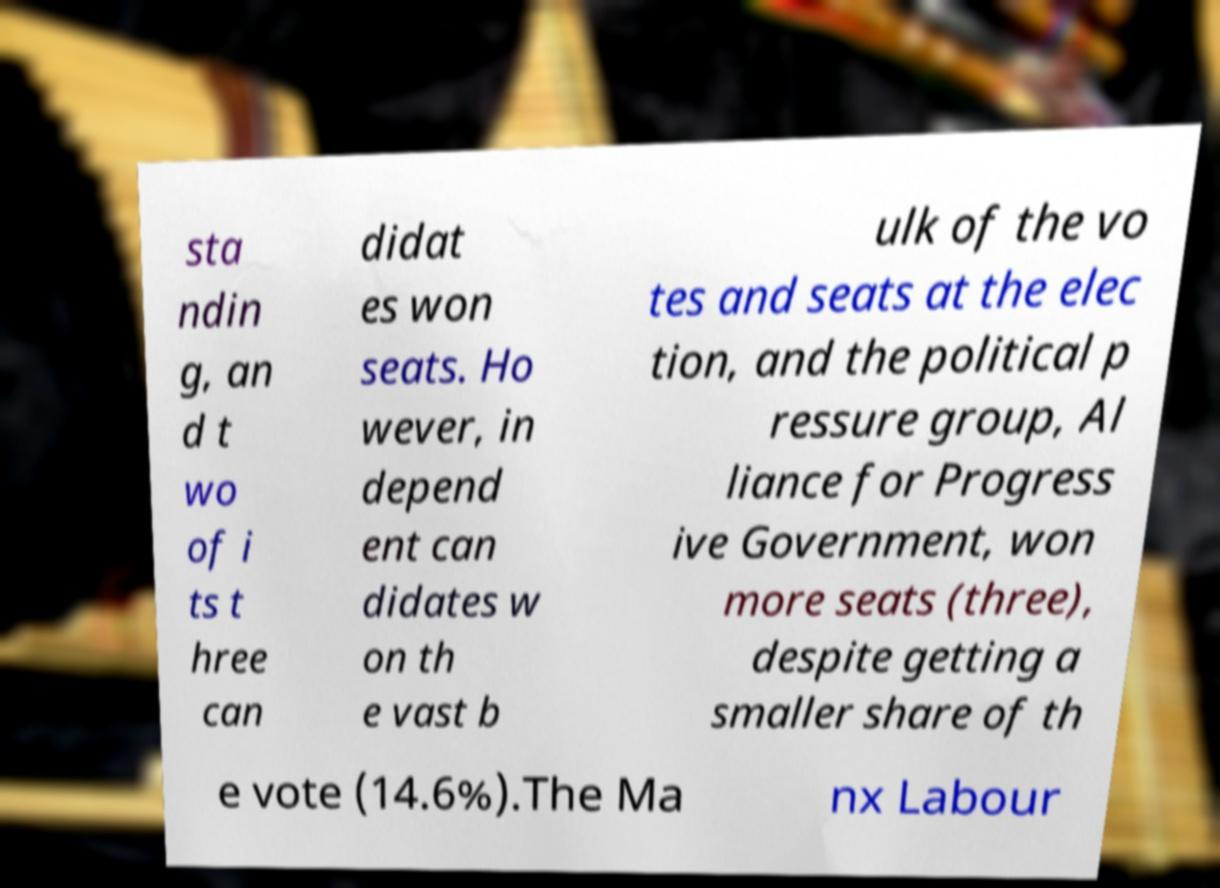Please identify and transcribe the text found in this image. sta ndin g, an d t wo of i ts t hree can didat es won seats. Ho wever, in depend ent can didates w on th e vast b ulk of the vo tes and seats at the elec tion, and the political p ressure group, Al liance for Progress ive Government, won more seats (three), despite getting a smaller share of th e vote (14.6%).The Ma nx Labour 